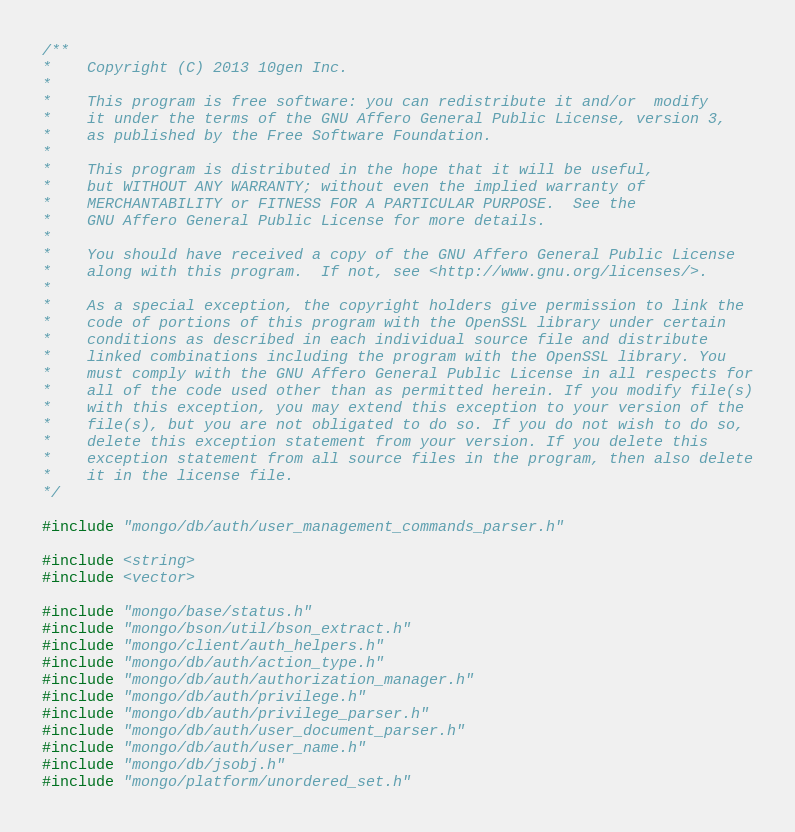<code> <loc_0><loc_0><loc_500><loc_500><_C++_>/**
*    Copyright (C) 2013 10gen Inc.
*
*    This program is free software: you can redistribute it and/or  modify
*    it under the terms of the GNU Affero General Public License, version 3,
*    as published by the Free Software Foundation.
*
*    This program is distributed in the hope that it will be useful,
*    but WITHOUT ANY WARRANTY; without even the implied warranty of
*    MERCHANTABILITY or FITNESS FOR A PARTICULAR PURPOSE.  See the
*    GNU Affero General Public License for more details.
*
*    You should have received a copy of the GNU Affero General Public License
*    along with this program.  If not, see <http://www.gnu.org/licenses/>.
*
*    As a special exception, the copyright holders give permission to link the
*    code of portions of this program with the OpenSSL library under certain
*    conditions as described in each individual source file and distribute
*    linked combinations including the program with the OpenSSL library. You
*    must comply with the GNU Affero General Public License in all respects for
*    all of the code used other than as permitted herein. If you modify file(s)
*    with this exception, you may extend this exception to your version of the
*    file(s), but you are not obligated to do so. If you do not wish to do so,
*    delete this exception statement from your version. If you delete this
*    exception statement from all source files in the program, then also delete
*    it in the license file.
*/

#include "mongo/db/auth/user_management_commands_parser.h"

#include <string>
#include <vector>

#include "mongo/base/status.h"
#include "mongo/bson/util/bson_extract.h"
#include "mongo/client/auth_helpers.h"
#include "mongo/db/auth/action_type.h"
#include "mongo/db/auth/authorization_manager.h"
#include "mongo/db/auth/privilege.h"
#include "mongo/db/auth/privilege_parser.h"
#include "mongo/db/auth/user_document_parser.h"
#include "mongo/db/auth/user_name.h"
#include "mongo/db/jsobj.h"
#include "mongo/platform/unordered_set.h"</code> 